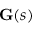Convert formula to latex. <formula><loc_0><loc_0><loc_500><loc_500>G ( s )</formula> 